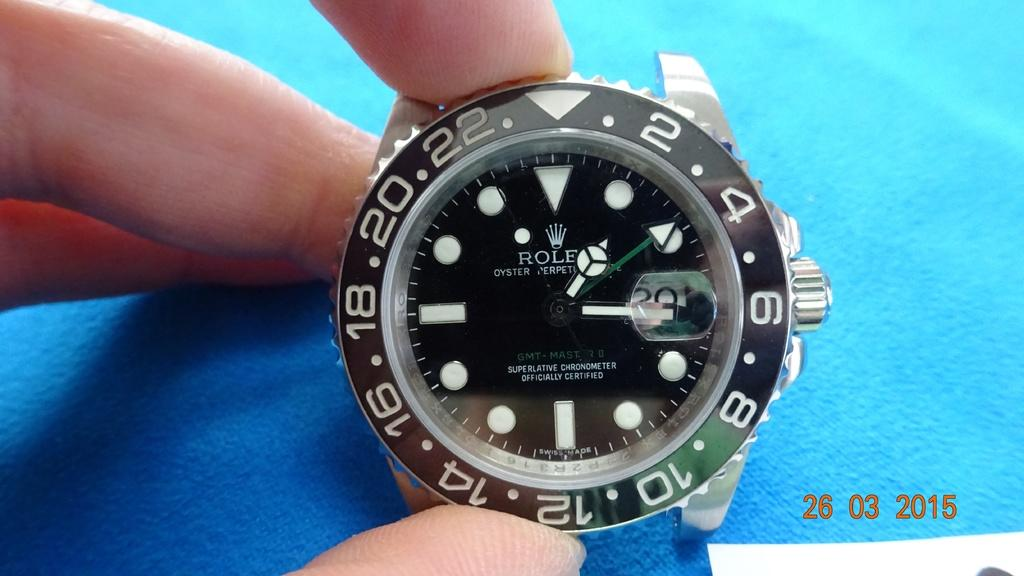<image>
Provide a brief description of the given image. A close up of a Rolex watch from 2015. 